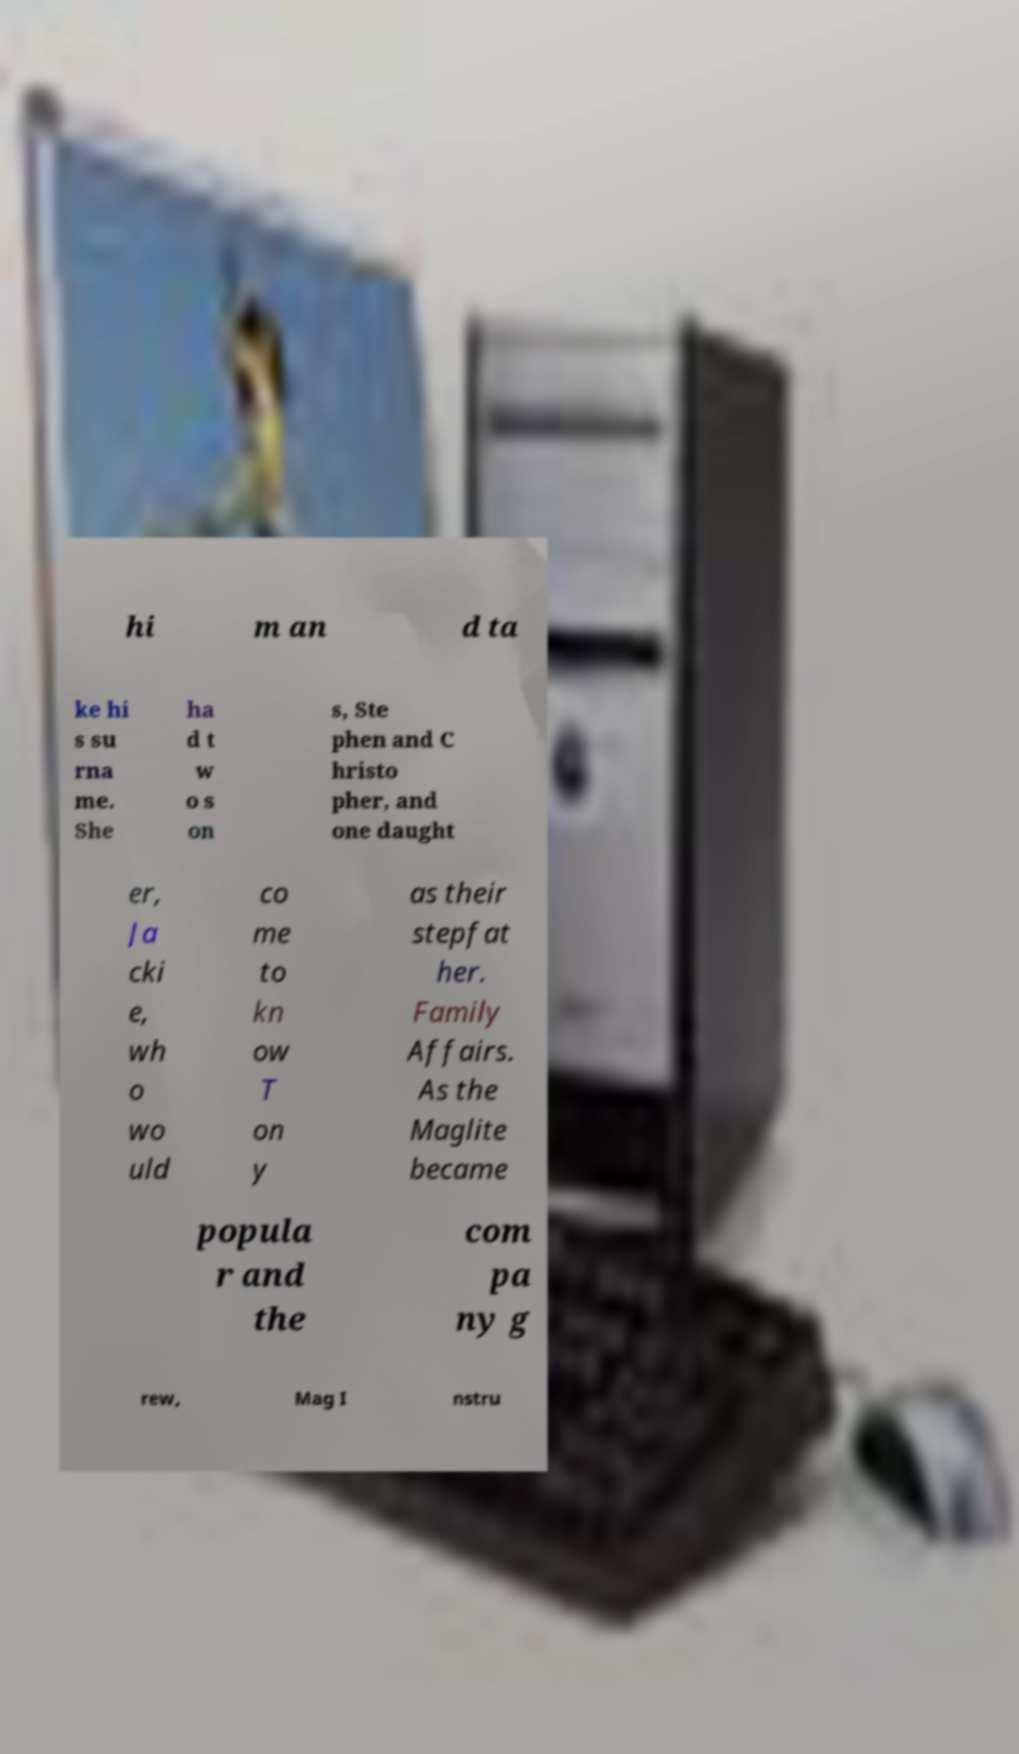For documentation purposes, I need the text within this image transcribed. Could you provide that? hi m an d ta ke hi s su rna me. She ha d t w o s on s, Ste phen and C hristo pher, and one daught er, Ja cki e, wh o wo uld co me to kn ow T on y as their stepfat her. Family Affairs. As the Maglite became popula r and the com pa ny g rew, Mag I nstru 